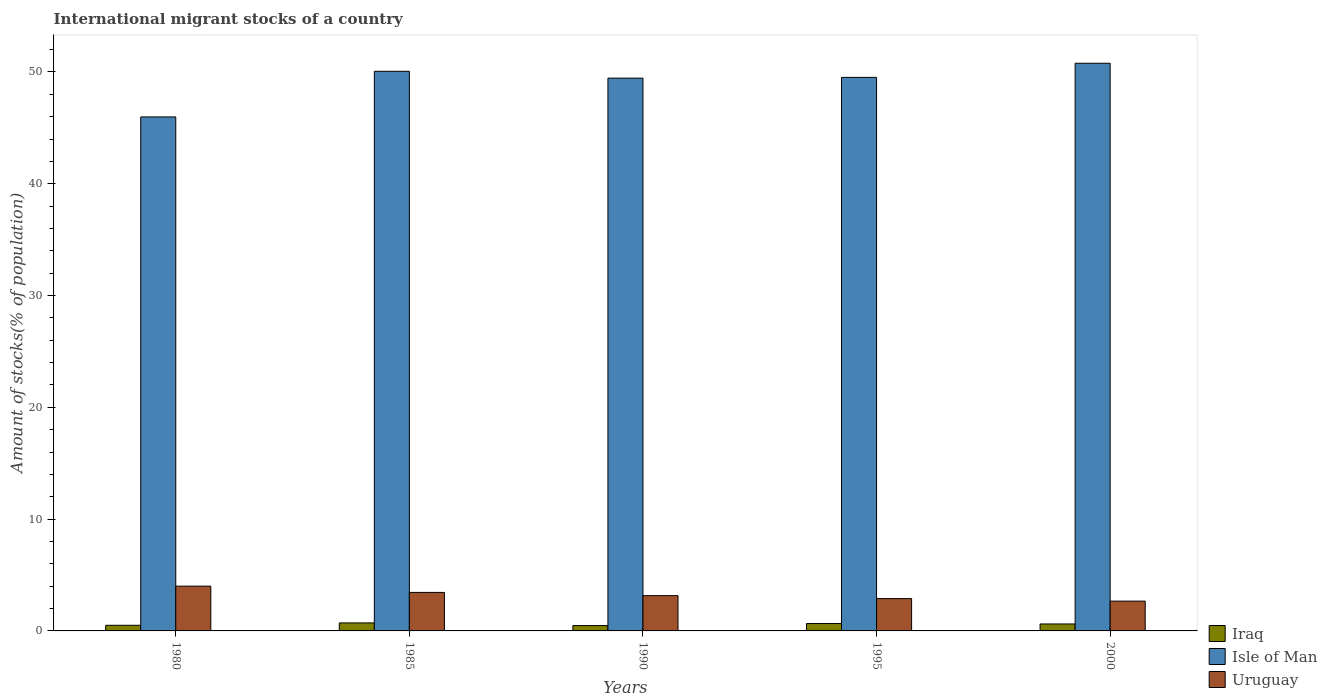How many different coloured bars are there?
Your answer should be very brief. 3. How many groups of bars are there?
Offer a terse response. 5. Are the number of bars per tick equal to the number of legend labels?
Make the answer very short. Yes. How many bars are there on the 5th tick from the left?
Your response must be concise. 3. What is the amount of stocks in in Isle of Man in 1985?
Provide a short and direct response. 50.06. Across all years, what is the maximum amount of stocks in in Uruguay?
Provide a short and direct response. 4.01. Across all years, what is the minimum amount of stocks in in Iraq?
Provide a short and direct response. 0.48. What is the total amount of stocks in in Isle of Man in the graph?
Provide a succinct answer. 245.78. What is the difference between the amount of stocks in in Iraq in 1995 and that in 2000?
Keep it short and to the point. 0.04. What is the difference between the amount of stocks in in Uruguay in 2000 and the amount of stocks in in Iraq in 1985?
Give a very brief answer. 1.95. What is the average amount of stocks in in Uruguay per year?
Keep it short and to the point. 3.23. In the year 1985, what is the difference between the amount of stocks in in Uruguay and amount of stocks in in Iraq?
Your response must be concise. 2.73. In how many years, is the amount of stocks in in Isle of Man greater than 22 %?
Your answer should be compact. 5. What is the ratio of the amount of stocks in in Isle of Man in 1985 to that in 1990?
Offer a very short reply. 1.01. Is the amount of stocks in in Isle of Man in 1980 less than that in 1990?
Your answer should be very brief. Yes. What is the difference between the highest and the second highest amount of stocks in in Uruguay?
Keep it short and to the point. 0.56. What is the difference between the highest and the lowest amount of stocks in in Uruguay?
Give a very brief answer. 1.34. In how many years, is the amount of stocks in in Isle of Man greater than the average amount of stocks in in Isle of Man taken over all years?
Give a very brief answer. 4. What does the 2nd bar from the left in 1995 represents?
Make the answer very short. Isle of Man. What does the 2nd bar from the right in 1980 represents?
Your answer should be compact. Isle of Man. Is it the case that in every year, the sum of the amount of stocks in in Iraq and amount of stocks in in Isle of Man is greater than the amount of stocks in in Uruguay?
Offer a terse response. Yes. How many bars are there?
Your answer should be compact. 15. Are all the bars in the graph horizontal?
Keep it short and to the point. No. What is the title of the graph?
Offer a terse response. International migrant stocks of a country. What is the label or title of the X-axis?
Your answer should be compact. Years. What is the label or title of the Y-axis?
Keep it short and to the point. Amount of stocks(% of population). What is the Amount of stocks(% of population) in Iraq in 1980?
Make the answer very short. 0.5. What is the Amount of stocks(% of population) in Isle of Man in 1980?
Provide a succinct answer. 45.98. What is the Amount of stocks(% of population) in Uruguay in 1980?
Give a very brief answer. 4.01. What is the Amount of stocks(% of population) of Iraq in 1985?
Your answer should be very brief. 0.72. What is the Amount of stocks(% of population) of Isle of Man in 1985?
Offer a very short reply. 50.06. What is the Amount of stocks(% of population) of Uruguay in 1985?
Offer a terse response. 3.45. What is the Amount of stocks(% of population) in Iraq in 1990?
Ensure brevity in your answer.  0.48. What is the Amount of stocks(% of population) of Isle of Man in 1990?
Your answer should be very brief. 49.45. What is the Amount of stocks(% of population) in Uruguay in 1990?
Your answer should be very brief. 3.16. What is the Amount of stocks(% of population) of Iraq in 1995?
Keep it short and to the point. 0.66. What is the Amount of stocks(% of population) in Isle of Man in 1995?
Keep it short and to the point. 49.52. What is the Amount of stocks(% of population) of Uruguay in 1995?
Keep it short and to the point. 2.89. What is the Amount of stocks(% of population) of Iraq in 2000?
Provide a succinct answer. 0.62. What is the Amount of stocks(% of population) of Isle of Man in 2000?
Ensure brevity in your answer.  50.78. What is the Amount of stocks(% of population) in Uruguay in 2000?
Make the answer very short. 2.67. Across all years, what is the maximum Amount of stocks(% of population) in Iraq?
Keep it short and to the point. 0.72. Across all years, what is the maximum Amount of stocks(% of population) in Isle of Man?
Make the answer very short. 50.78. Across all years, what is the maximum Amount of stocks(% of population) in Uruguay?
Provide a short and direct response. 4.01. Across all years, what is the minimum Amount of stocks(% of population) in Iraq?
Provide a succinct answer. 0.48. Across all years, what is the minimum Amount of stocks(% of population) of Isle of Man?
Your answer should be compact. 45.98. Across all years, what is the minimum Amount of stocks(% of population) of Uruguay?
Keep it short and to the point. 2.67. What is the total Amount of stocks(% of population) of Iraq in the graph?
Offer a very short reply. 2.98. What is the total Amount of stocks(% of population) of Isle of Man in the graph?
Your answer should be compact. 245.78. What is the total Amount of stocks(% of population) in Uruguay in the graph?
Offer a terse response. 16.16. What is the difference between the Amount of stocks(% of population) of Iraq in 1980 and that in 1985?
Your response must be concise. -0.21. What is the difference between the Amount of stocks(% of population) of Isle of Man in 1980 and that in 1985?
Your answer should be very brief. -4.08. What is the difference between the Amount of stocks(% of population) of Uruguay in 1980 and that in 1985?
Your answer should be compact. 0.56. What is the difference between the Amount of stocks(% of population) of Iraq in 1980 and that in 1990?
Your answer should be very brief. 0.03. What is the difference between the Amount of stocks(% of population) in Isle of Man in 1980 and that in 1990?
Provide a succinct answer. -3.47. What is the difference between the Amount of stocks(% of population) of Uruguay in 1980 and that in 1990?
Give a very brief answer. 0.85. What is the difference between the Amount of stocks(% of population) in Iraq in 1980 and that in 1995?
Your answer should be compact. -0.16. What is the difference between the Amount of stocks(% of population) in Isle of Man in 1980 and that in 1995?
Your response must be concise. -3.54. What is the difference between the Amount of stocks(% of population) of Uruguay in 1980 and that in 1995?
Keep it short and to the point. 1.11. What is the difference between the Amount of stocks(% of population) in Iraq in 1980 and that in 2000?
Give a very brief answer. -0.12. What is the difference between the Amount of stocks(% of population) of Isle of Man in 1980 and that in 2000?
Your answer should be very brief. -4.8. What is the difference between the Amount of stocks(% of population) of Uruguay in 1980 and that in 2000?
Your answer should be very brief. 1.34. What is the difference between the Amount of stocks(% of population) of Iraq in 1985 and that in 1990?
Provide a succinct answer. 0.24. What is the difference between the Amount of stocks(% of population) of Isle of Man in 1985 and that in 1990?
Keep it short and to the point. 0.61. What is the difference between the Amount of stocks(% of population) of Uruguay in 1985 and that in 1990?
Keep it short and to the point. 0.29. What is the difference between the Amount of stocks(% of population) in Iraq in 1985 and that in 1995?
Provide a short and direct response. 0.06. What is the difference between the Amount of stocks(% of population) of Isle of Man in 1985 and that in 1995?
Offer a very short reply. 0.54. What is the difference between the Amount of stocks(% of population) in Uruguay in 1985 and that in 1995?
Your response must be concise. 0.55. What is the difference between the Amount of stocks(% of population) of Iraq in 1985 and that in 2000?
Make the answer very short. 0.09. What is the difference between the Amount of stocks(% of population) of Isle of Man in 1985 and that in 2000?
Make the answer very short. -0.72. What is the difference between the Amount of stocks(% of population) in Uruguay in 1985 and that in 2000?
Provide a short and direct response. 0.78. What is the difference between the Amount of stocks(% of population) of Iraq in 1990 and that in 1995?
Ensure brevity in your answer.  -0.18. What is the difference between the Amount of stocks(% of population) of Isle of Man in 1990 and that in 1995?
Your answer should be compact. -0.07. What is the difference between the Amount of stocks(% of population) in Uruguay in 1990 and that in 1995?
Ensure brevity in your answer.  0.27. What is the difference between the Amount of stocks(% of population) of Iraq in 1990 and that in 2000?
Your response must be concise. -0.14. What is the difference between the Amount of stocks(% of population) of Isle of Man in 1990 and that in 2000?
Your response must be concise. -1.33. What is the difference between the Amount of stocks(% of population) of Uruguay in 1990 and that in 2000?
Provide a succinct answer. 0.49. What is the difference between the Amount of stocks(% of population) in Iraq in 1995 and that in 2000?
Keep it short and to the point. 0.04. What is the difference between the Amount of stocks(% of population) of Isle of Man in 1995 and that in 2000?
Ensure brevity in your answer.  -1.26. What is the difference between the Amount of stocks(% of population) in Uruguay in 1995 and that in 2000?
Your answer should be compact. 0.22. What is the difference between the Amount of stocks(% of population) of Iraq in 1980 and the Amount of stocks(% of population) of Isle of Man in 1985?
Provide a short and direct response. -49.56. What is the difference between the Amount of stocks(% of population) in Iraq in 1980 and the Amount of stocks(% of population) in Uruguay in 1985?
Offer a terse response. -2.94. What is the difference between the Amount of stocks(% of population) in Isle of Man in 1980 and the Amount of stocks(% of population) in Uruguay in 1985?
Ensure brevity in your answer.  42.53. What is the difference between the Amount of stocks(% of population) of Iraq in 1980 and the Amount of stocks(% of population) of Isle of Man in 1990?
Ensure brevity in your answer.  -48.95. What is the difference between the Amount of stocks(% of population) of Iraq in 1980 and the Amount of stocks(% of population) of Uruguay in 1990?
Ensure brevity in your answer.  -2.65. What is the difference between the Amount of stocks(% of population) of Isle of Man in 1980 and the Amount of stocks(% of population) of Uruguay in 1990?
Your answer should be very brief. 42.82. What is the difference between the Amount of stocks(% of population) of Iraq in 1980 and the Amount of stocks(% of population) of Isle of Man in 1995?
Your answer should be very brief. -49.01. What is the difference between the Amount of stocks(% of population) of Iraq in 1980 and the Amount of stocks(% of population) of Uruguay in 1995?
Offer a terse response. -2.39. What is the difference between the Amount of stocks(% of population) in Isle of Man in 1980 and the Amount of stocks(% of population) in Uruguay in 1995?
Offer a very short reply. 43.09. What is the difference between the Amount of stocks(% of population) of Iraq in 1980 and the Amount of stocks(% of population) of Isle of Man in 2000?
Offer a terse response. -50.28. What is the difference between the Amount of stocks(% of population) of Iraq in 1980 and the Amount of stocks(% of population) of Uruguay in 2000?
Make the answer very short. -2.16. What is the difference between the Amount of stocks(% of population) of Isle of Man in 1980 and the Amount of stocks(% of population) of Uruguay in 2000?
Your answer should be very brief. 43.31. What is the difference between the Amount of stocks(% of population) in Iraq in 1985 and the Amount of stocks(% of population) in Isle of Man in 1990?
Provide a short and direct response. -48.73. What is the difference between the Amount of stocks(% of population) in Iraq in 1985 and the Amount of stocks(% of population) in Uruguay in 1990?
Give a very brief answer. -2.44. What is the difference between the Amount of stocks(% of population) in Isle of Man in 1985 and the Amount of stocks(% of population) in Uruguay in 1990?
Provide a succinct answer. 46.9. What is the difference between the Amount of stocks(% of population) of Iraq in 1985 and the Amount of stocks(% of population) of Isle of Man in 1995?
Your response must be concise. -48.8. What is the difference between the Amount of stocks(% of population) of Iraq in 1985 and the Amount of stocks(% of population) of Uruguay in 1995?
Offer a very short reply. -2.17. What is the difference between the Amount of stocks(% of population) in Isle of Man in 1985 and the Amount of stocks(% of population) in Uruguay in 1995?
Offer a terse response. 47.17. What is the difference between the Amount of stocks(% of population) in Iraq in 1985 and the Amount of stocks(% of population) in Isle of Man in 2000?
Offer a terse response. -50.06. What is the difference between the Amount of stocks(% of population) in Iraq in 1985 and the Amount of stocks(% of population) in Uruguay in 2000?
Give a very brief answer. -1.95. What is the difference between the Amount of stocks(% of population) of Isle of Man in 1985 and the Amount of stocks(% of population) of Uruguay in 2000?
Make the answer very short. 47.39. What is the difference between the Amount of stocks(% of population) of Iraq in 1990 and the Amount of stocks(% of population) of Isle of Man in 1995?
Provide a succinct answer. -49.04. What is the difference between the Amount of stocks(% of population) in Iraq in 1990 and the Amount of stocks(% of population) in Uruguay in 1995?
Your answer should be compact. -2.41. What is the difference between the Amount of stocks(% of population) in Isle of Man in 1990 and the Amount of stocks(% of population) in Uruguay in 1995?
Offer a very short reply. 46.56. What is the difference between the Amount of stocks(% of population) of Iraq in 1990 and the Amount of stocks(% of population) of Isle of Man in 2000?
Keep it short and to the point. -50.3. What is the difference between the Amount of stocks(% of population) in Iraq in 1990 and the Amount of stocks(% of population) in Uruguay in 2000?
Keep it short and to the point. -2.19. What is the difference between the Amount of stocks(% of population) in Isle of Man in 1990 and the Amount of stocks(% of population) in Uruguay in 2000?
Give a very brief answer. 46.78. What is the difference between the Amount of stocks(% of population) in Iraq in 1995 and the Amount of stocks(% of population) in Isle of Man in 2000?
Make the answer very short. -50.12. What is the difference between the Amount of stocks(% of population) of Iraq in 1995 and the Amount of stocks(% of population) of Uruguay in 2000?
Your answer should be very brief. -2. What is the difference between the Amount of stocks(% of population) of Isle of Man in 1995 and the Amount of stocks(% of population) of Uruguay in 2000?
Offer a very short reply. 46.85. What is the average Amount of stocks(% of population) in Iraq per year?
Your answer should be compact. 0.6. What is the average Amount of stocks(% of population) in Isle of Man per year?
Offer a very short reply. 49.16. What is the average Amount of stocks(% of population) in Uruguay per year?
Ensure brevity in your answer.  3.23. In the year 1980, what is the difference between the Amount of stocks(% of population) in Iraq and Amount of stocks(% of population) in Isle of Man?
Ensure brevity in your answer.  -45.47. In the year 1980, what is the difference between the Amount of stocks(% of population) in Iraq and Amount of stocks(% of population) in Uruguay?
Your answer should be compact. -3.5. In the year 1980, what is the difference between the Amount of stocks(% of population) in Isle of Man and Amount of stocks(% of population) in Uruguay?
Your answer should be very brief. 41.97. In the year 1985, what is the difference between the Amount of stocks(% of population) in Iraq and Amount of stocks(% of population) in Isle of Man?
Offer a very short reply. -49.34. In the year 1985, what is the difference between the Amount of stocks(% of population) in Iraq and Amount of stocks(% of population) in Uruguay?
Offer a terse response. -2.73. In the year 1985, what is the difference between the Amount of stocks(% of population) of Isle of Man and Amount of stocks(% of population) of Uruguay?
Your response must be concise. 46.62. In the year 1990, what is the difference between the Amount of stocks(% of population) in Iraq and Amount of stocks(% of population) in Isle of Man?
Your answer should be very brief. -48.97. In the year 1990, what is the difference between the Amount of stocks(% of population) in Iraq and Amount of stocks(% of population) in Uruguay?
Offer a very short reply. -2.68. In the year 1990, what is the difference between the Amount of stocks(% of population) in Isle of Man and Amount of stocks(% of population) in Uruguay?
Make the answer very short. 46.29. In the year 1995, what is the difference between the Amount of stocks(% of population) in Iraq and Amount of stocks(% of population) in Isle of Man?
Give a very brief answer. -48.85. In the year 1995, what is the difference between the Amount of stocks(% of population) of Iraq and Amount of stocks(% of population) of Uruguay?
Provide a succinct answer. -2.23. In the year 1995, what is the difference between the Amount of stocks(% of population) in Isle of Man and Amount of stocks(% of population) in Uruguay?
Provide a short and direct response. 46.62. In the year 2000, what is the difference between the Amount of stocks(% of population) of Iraq and Amount of stocks(% of population) of Isle of Man?
Ensure brevity in your answer.  -50.16. In the year 2000, what is the difference between the Amount of stocks(% of population) in Iraq and Amount of stocks(% of population) in Uruguay?
Your response must be concise. -2.04. In the year 2000, what is the difference between the Amount of stocks(% of population) of Isle of Man and Amount of stocks(% of population) of Uruguay?
Your response must be concise. 48.11. What is the ratio of the Amount of stocks(% of population) in Iraq in 1980 to that in 1985?
Make the answer very short. 0.7. What is the ratio of the Amount of stocks(% of population) in Isle of Man in 1980 to that in 1985?
Give a very brief answer. 0.92. What is the ratio of the Amount of stocks(% of population) of Uruguay in 1980 to that in 1985?
Offer a terse response. 1.16. What is the ratio of the Amount of stocks(% of population) of Iraq in 1980 to that in 1990?
Make the answer very short. 1.05. What is the ratio of the Amount of stocks(% of population) in Isle of Man in 1980 to that in 1990?
Give a very brief answer. 0.93. What is the ratio of the Amount of stocks(% of population) in Uruguay in 1980 to that in 1990?
Your response must be concise. 1.27. What is the ratio of the Amount of stocks(% of population) in Iraq in 1980 to that in 1995?
Your answer should be compact. 0.76. What is the ratio of the Amount of stocks(% of population) of Isle of Man in 1980 to that in 1995?
Keep it short and to the point. 0.93. What is the ratio of the Amount of stocks(% of population) in Uruguay in 1980 to that in 1995?
Your answer should be compact. 1.39. What is the ratio of the Amount of stocks(% of population) of Iraq in 1980 to that in 2000?
Make the answer very short. 0.81. What is the ratio of the Amount of stocks(% of population) of Isle of Man in 1980 to that in 2000?
Your answer should be very brief. 0.91. What is the ratio of the Amount of stocks(% of population) in Uruguay in 1980 to that in 2000?
Your response must be concise. 1.5. What is the ratio of the Amount of stocks(% of population) in Iraq in 1985 to that in 1990?
Your answer should be very brief. 1.5. What is the ratio of the Amount of stocks(% of population) in Isle of Man in 1985 to that in 1990?
Offer a very short reply. 1.01. What is the ratio of the Amount of stocks(% of population) in Uruguay in 1985 to that in 1990?
Your answer should be compact. 1.09. What is the ratio of the Amount of stocks(% of population) of Iraq in 1985 to that in 1995?
Make the answer very short. 1.08. What is the ratio of the Amount of stocks(% of population) in Uruguay in 1985 to that in 1995?
Provide a succinct answer. 1.19. What is the ratio of the Amount of stocks(% of population) of Iraq in 1985 to that in 2000?
Your response must be concise. 1.15. What is the ratio of the Amount of stocks(% of population) of Isle of Man in 1985 to that in 2000?
Offer a very short reply. 0.99. What is the ratio of the Amount of stocks(% of population) in Uruguay in 1985 to that in 2000?
Offer a very short reply. 1.29. What is the ratio of the Amount of stocks(% of population) of Iraq in 1990 to that in 1995?
Your response must be concise. 0.72. What is the ratio of the Amount of stocks(% of population) in Uruguay in 1990 to that in 1995?
Your answer should be very brief. 1.09. What is the ratio of the Amount of stocks(% of population) of Iraq in 1990 to that in 2000?
Give a very brief answer. 0.77. What is the ratio of the Amount of stocks(% of population) in Isle of Man in 1990 to that in 2000?
Offer a very short reply. 0.97. What is the ratio of the Amount of stocks(% of population) in Uruguay in 1990 to that in 2000?
Provide a short and direct response. 1.18. What is the ratio of the Amount of stocks(% of population) in Iraq in 1995 to that in 2000?
Your response must be concise. 1.06. What is the ratio of the Amount of stocks(% of population) in Isle of Man in 1995 to that in 2000?
Provide a short and direct response. 0.98. What is the ratio of the Amount of stocks(% of population) of Uruguay in 1995 to that in 2000?
Your answer should be compact. 1.08. What is the difference between the highest and the second highest Amount of stocks(% of population) of Iraq?
Provide a succinct answer. 0.06. What is the difference between the highest and the second highest Amount of stocks(% of population) of Isle of Man?
Make the answer very short. 0.72. What is the difference between the highest and the second highest Amount of stocks(% of population) of Uruguay?
Provide a short and direct response. 0.56. What is the difference between the highest and the lowest Amount of stocks(% of population) in Iraq?
Offer a very short reply. 0.24. What is the difference between the highest and the lowest Amount of stocks(% of population) of Isle of Man?
Your answer should be very brief. 4.8. What is the difference between the highest and the lowest Amount of stocks(% of population) of Uruguay?
Give a very brief answer. 1.34. 